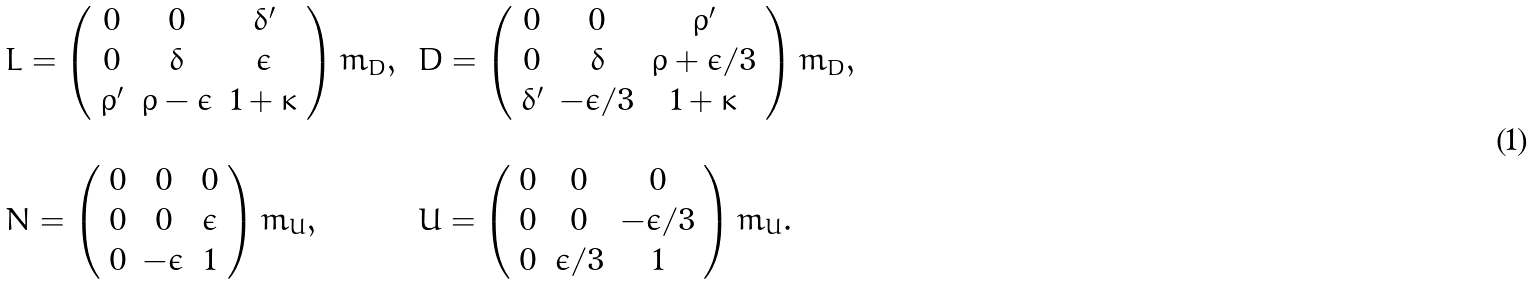<formula> <loc_0><loc_0><loc_500><loc_500>\begin{array} { l l } L = \left ( \begin{array} { c c c } 0 & 0 & \delta ^ { \prime } \\ 0 & \delta & \epsilon \\ \rho ^ { \prime } & \rho - \epsilon & 1 + \kappa \end{array} \right ) m _ { D } , \, & D = \left ( \begin{array} { c c c } 0 & 0 & \rho ^ { \prime } \\ 0 & \delta & \rho + \epsilon / 3 \\ \delta ^ { \prime } & - \epsilon / 3 & 1 + \kappa \end{array} \right ) m _ { D } , \\ \\ N = \left ( \begin{array} { c c c } 0 & 0 & 0 \\ 0 & 0 & \epsilon \\ 0 & - \epsilon & 1 \end{array} \right ) m _ { U } , \, & U = \left ( \begin{array} { c c c } 0 & 0 & 0 \\ 0 & 0 & - \epsilon / 3 \\ 0 & \epsilon / 3 & 1 \end{array} \right ) m _ { U } . \end{array}</formula> 